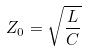<formula> <loc_0><loc_0><loc_500><loc_500>Z _ { 0 } = \sqrt { \frac { L } { C } }</formula> 